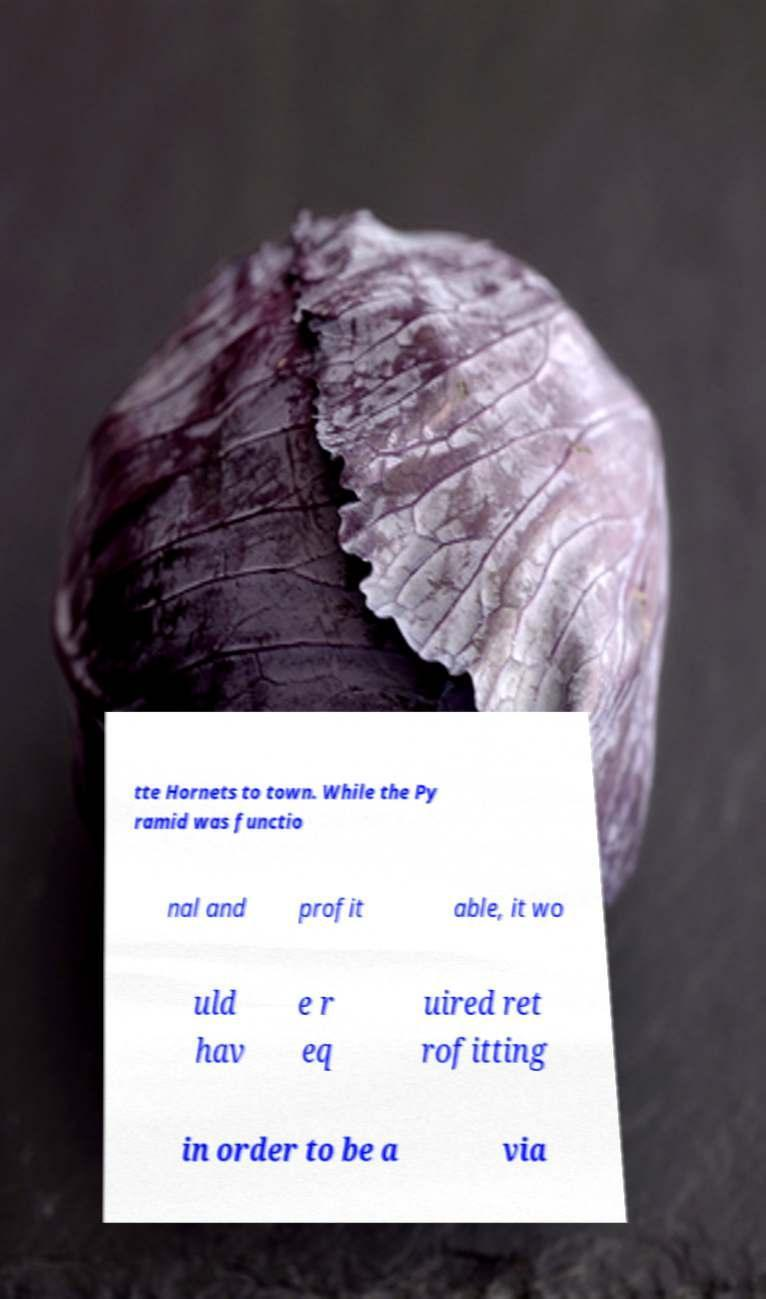Can you accurately transcribe the text from the provided image for me? tte Hornets to town. While the Py ramid was functio nal and profit able, it wo uld hav e r eq uired ret rofitting in order to be a via 